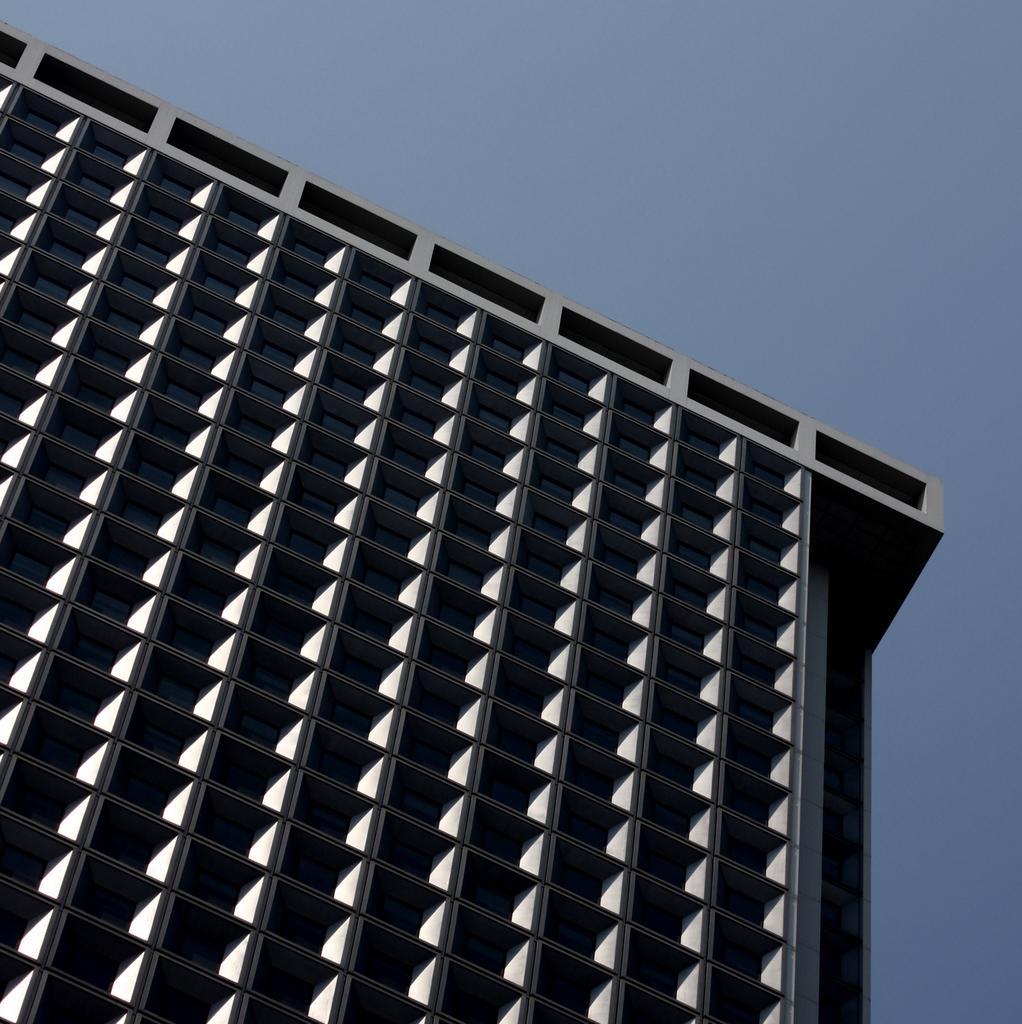How would you summarize this image in a sentence or two? In this image we can see a building and in the background, we can see the sky. 